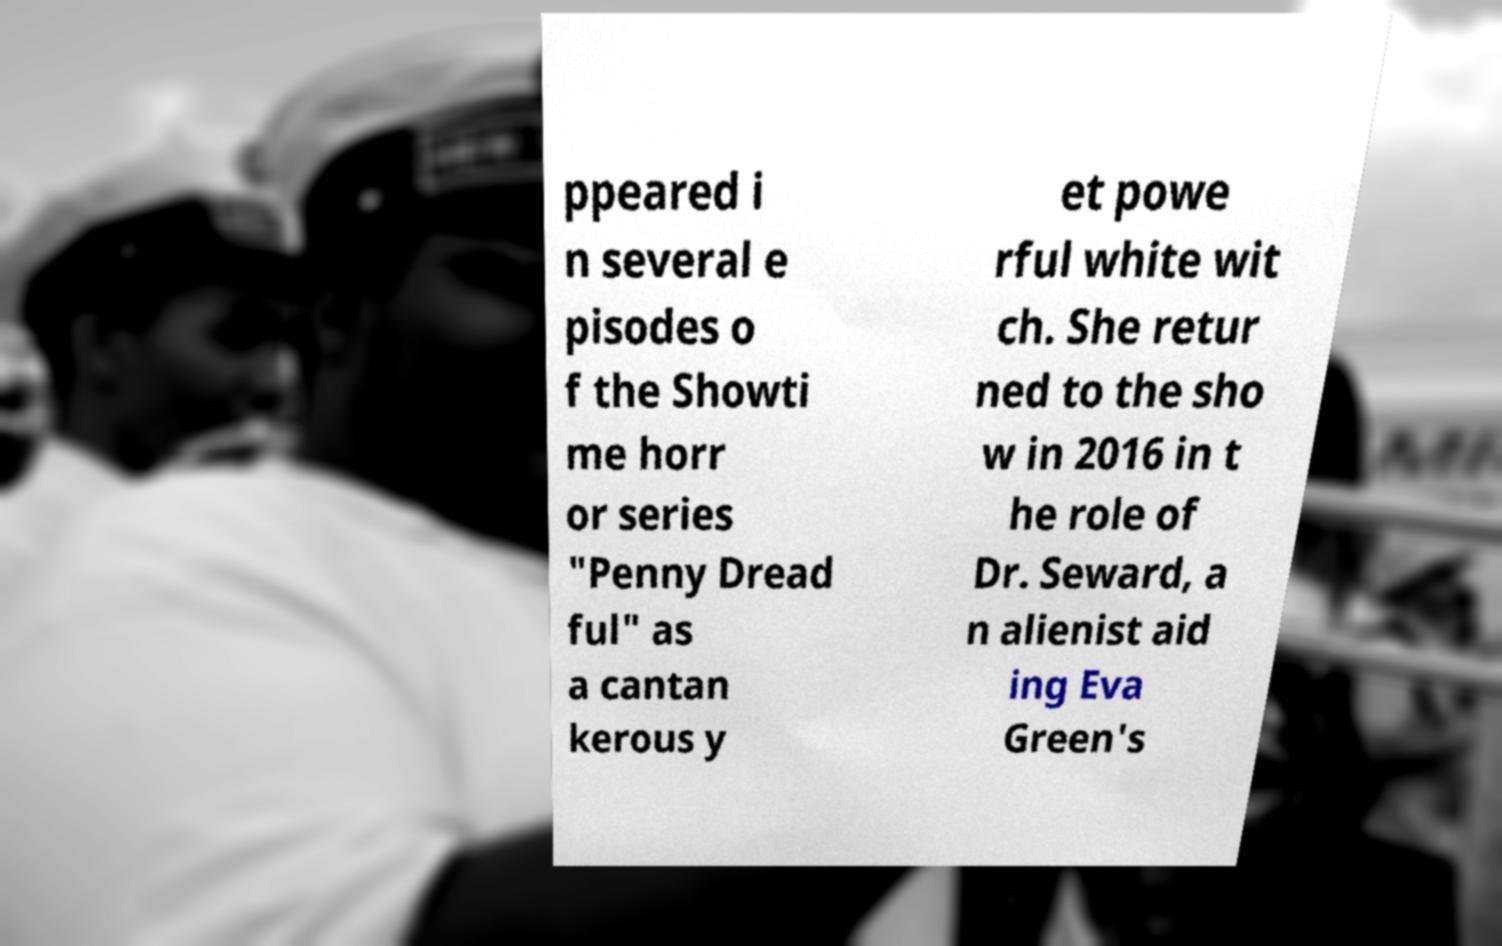What messages or text are displayed in this image? I need them in a readable, typed format. ppeared i n several e pisodes o f the Showti me horr or series "Penny Dread ful" as a cantan kerous y et powe rful white wit ch. She retur ned to the sho w in 2016 in t he role of Dr. Seward, a n alienist aid ing Eva Green's 